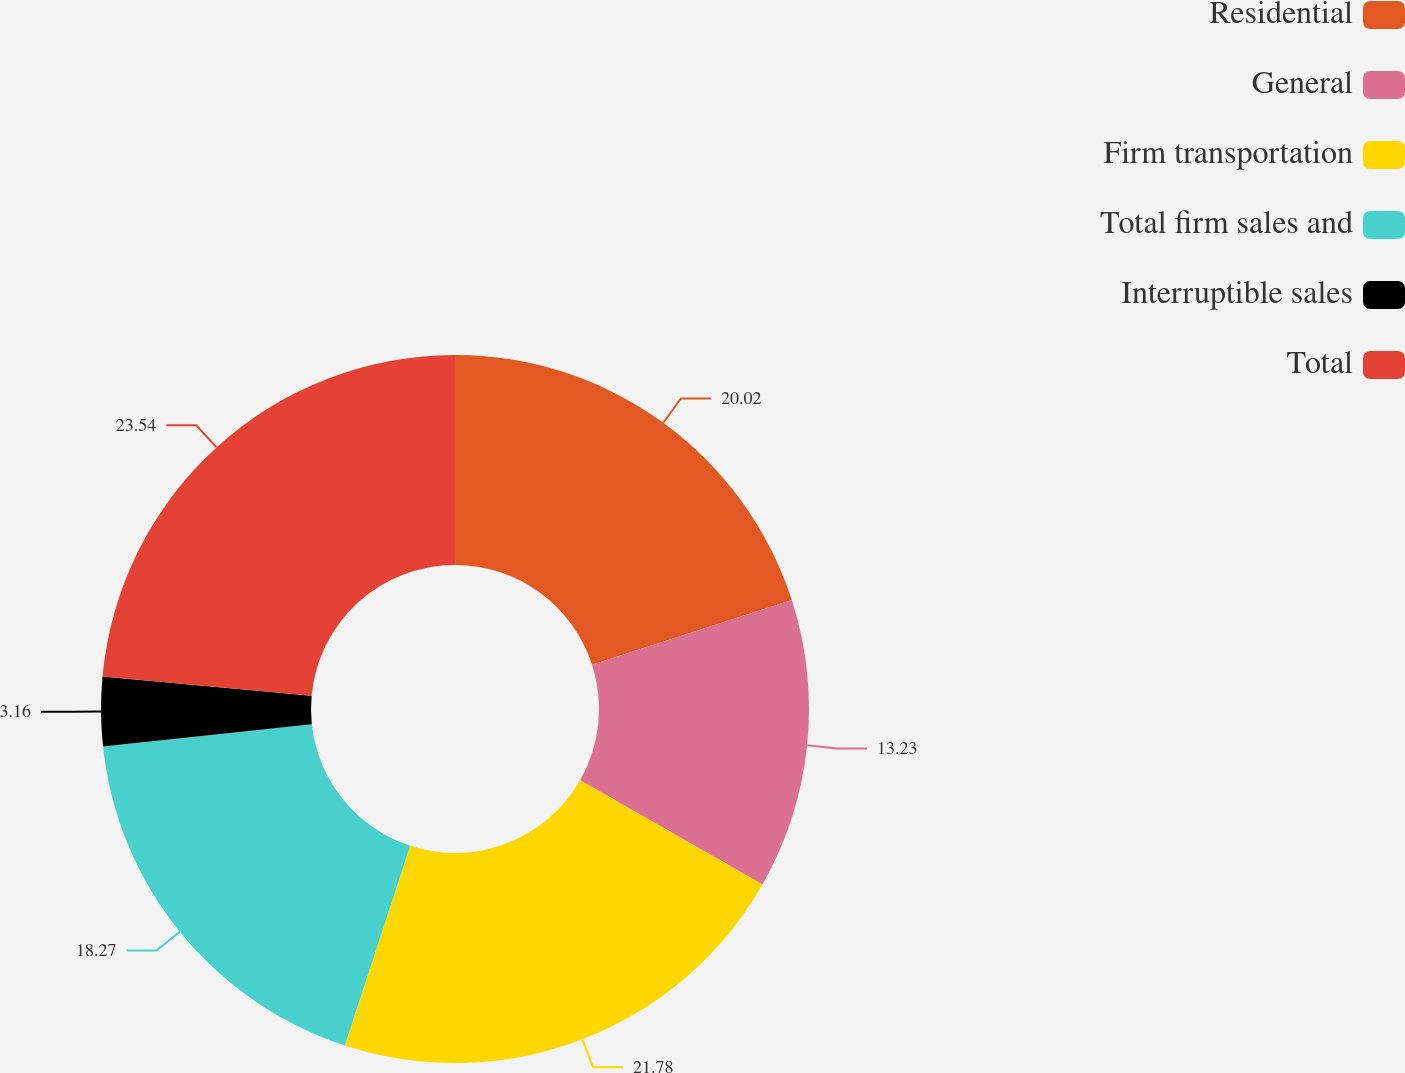Convert chart. <chart><loc_0><loc_0><loc_500><loc_500><pie_chart><fcel>Residential<fcel>General<fcel>Firm transportation<fcel>Total firm sales and<fcel>Interruptible sales<fcel>Total<nl><fcel>20.02%<fcel>13.23%<fcel>21.78%<fcel>18.27%<fcel>3.16%<fcel>23.53%<nl></chart> 